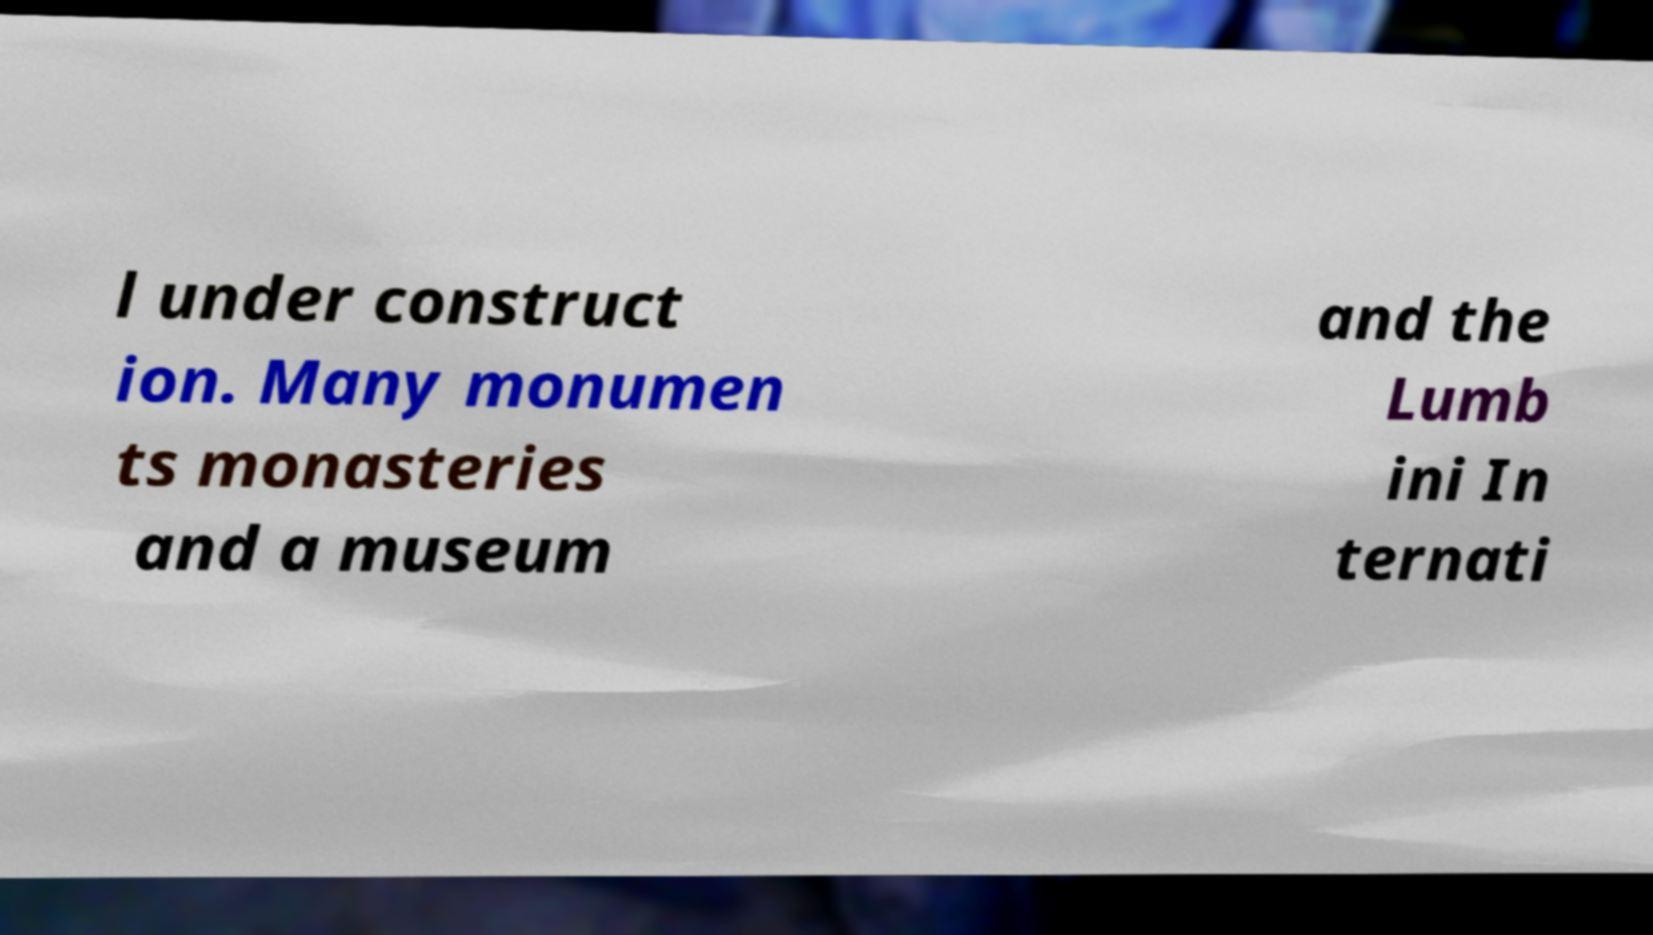Please read and relay the text visible in this image. What does it say? l under construct ion. Many monumen ts monasteries and a museum and the Lumb ini In ternati 